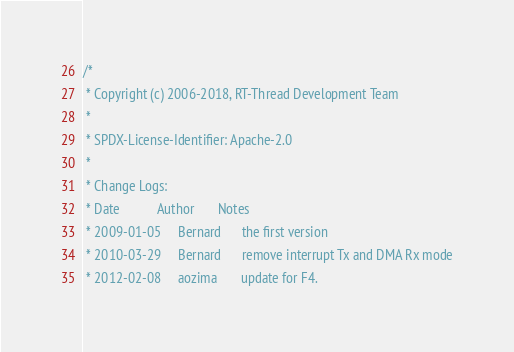<code> <loc_0><loc_0><loc_500><loc_500><_C_>/*
 * Copyright (c) 2006-2018, RT-Thread Development Team
 *
 * SPDX-License-Identifier: Apache-2.0
 *
 * Change Logs:
 * Date           Author       Notes
 * 2009-01-05     Bernard      the first version
 * 2010-03-29     Bernard      remove interrupt Tx and DMA Rx mode
 * 2012-02-08     aozima       update for F4.</code> 